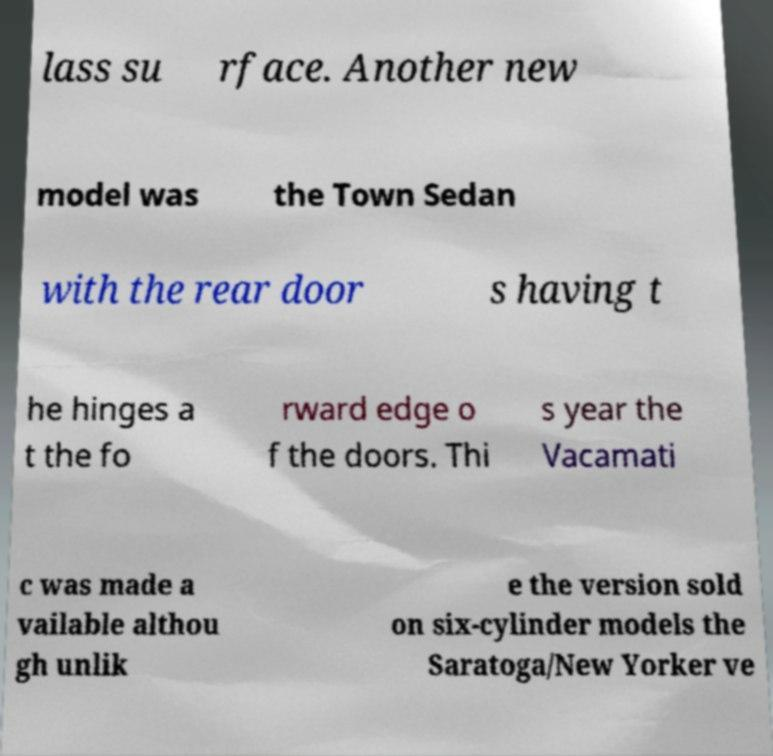Please read and relay the text visible in this image. What does it say? lass su rface. Another new model was the Town Sedan with the rear door s having t he hinges a t the fo rward edge o f the doors. Thi s year the Vacamati c was made a vailable althou gh unlik e the version sold on six-cylinder models the Saratoga/New Yorker ve 